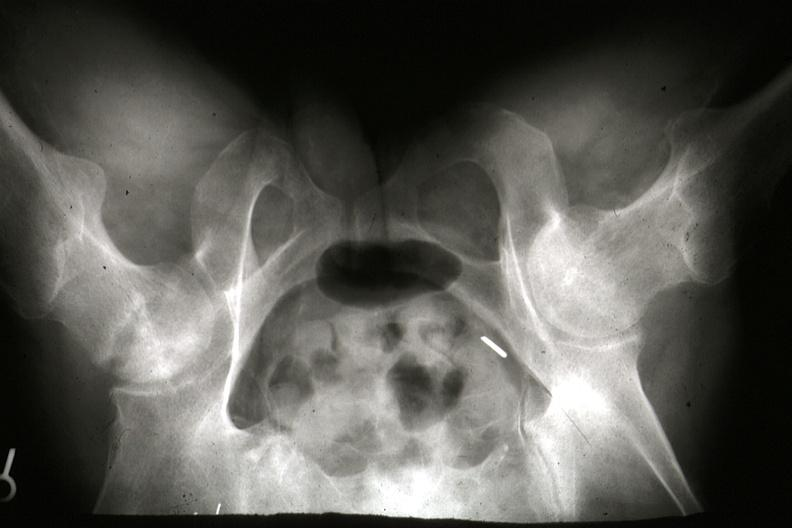what does this image show?
Answer the question using a single word or phrase. X-ray of pelvis during life showing osteonecrosis in right femoral head slides 7182 and 7183 are gross and postmortx-rays of lesion 